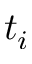<formula> <loc_0><loc_0><loc_500><loc_500>t _ { i }</formula> 